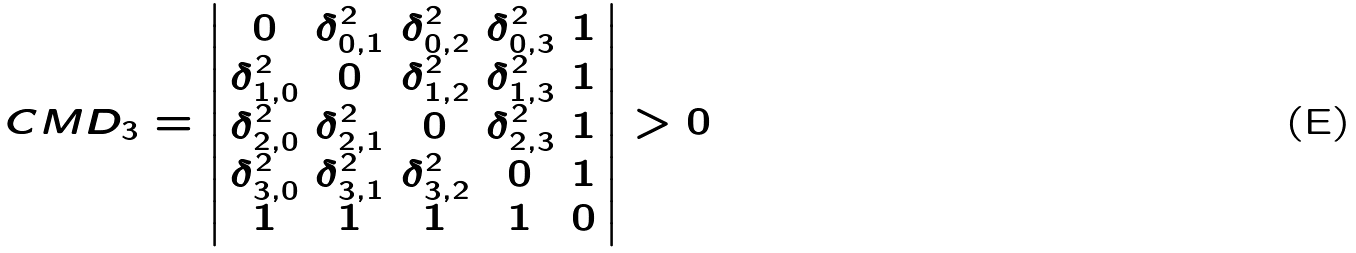<formula> <loc_0><loc_0><loc_500><loc_500>C M D _ { 3 } = \left | \begin{array} { c c c c c } 0 & \delta _ { 0 , 1 } ^ { 2 } & \delta _ { 0 , 2 } ^ { 2 } & \delta _ { 0 , 3 } ^ { 2 } & 1 \\ \delta _ { 1 , 0 } ^ { 2 } & 0 & \delta _ { 1 , 2 } ^ { 2 } & \delta _ { 1 , 3 } ^ { 2 } & 1 \\ \delta _ { 2 , 0 } ^ { 2 } & \delta _ { 2 , 1 } ^ { 2 } & 0 & \delta _ { 2 , 3 } ^ { 2 } & 1 \\ \delta _ { 3 , 0 } ^ { 2 } & \delta _ { 3 , 1 } ^ { 2 } & \delta _ { 3 , 2 } ^ { 2 } & 0 & 1 \\ 1 & 1 & 1 & 1 & 0 \end{array} \right | > 0</formula> 